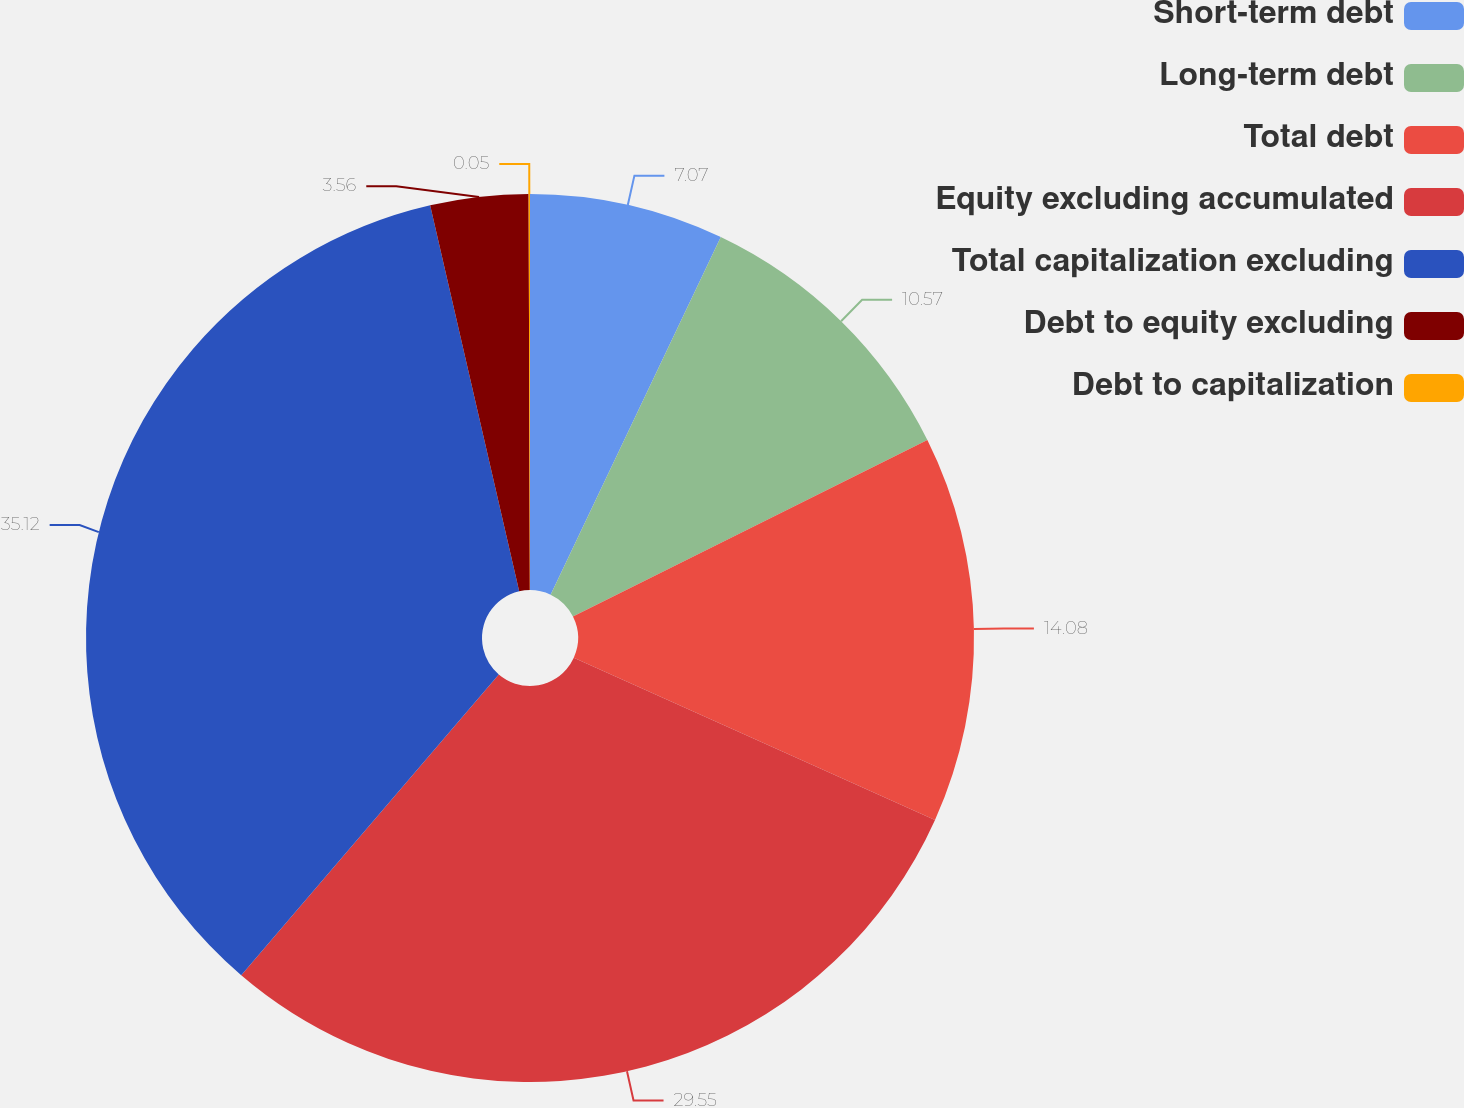Convert chart to OTSL. <chart><loc_0><loc_0><loc_500><loc_500><pie_chart><fcel>Short-term debt<fcel>Long-term debt<fcel>Total debt<fcel>Equity excluding accumulated<fcel>Total capitalization excluding<fcel>Debt to equity excluding<fcel>Debt to capitalization<nl><fcel>7.07%<fcel>10.57%<fcel>14.08%<fcel>29.55%<fcel>35.12%<fcel>3.56%<fcel>0.05%<nl></chart> 